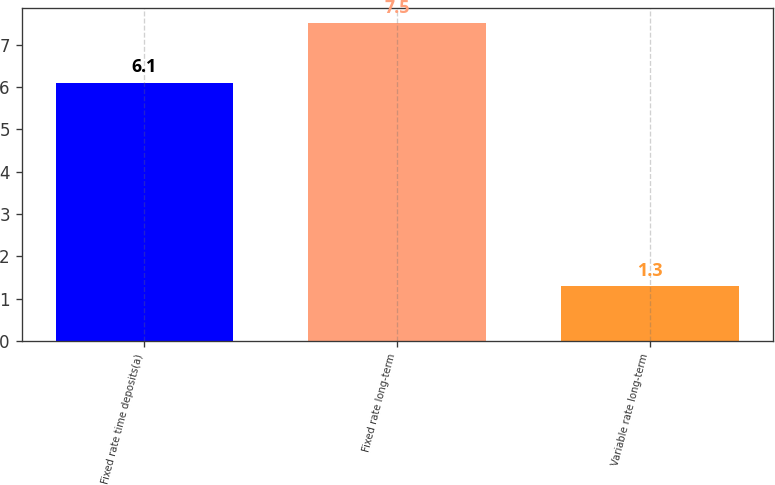Convert chart to OTSL. <chart><loc_0><loc_0><loc_500><loc_500><bar_chart><fcel>Fixed rate time deposits(a)<fcel>Fixed rate long-term<fcel>Variable rate long-term<nl><fcel>6.1<fcel>7.5<fcel>1.3<nl></chart> 